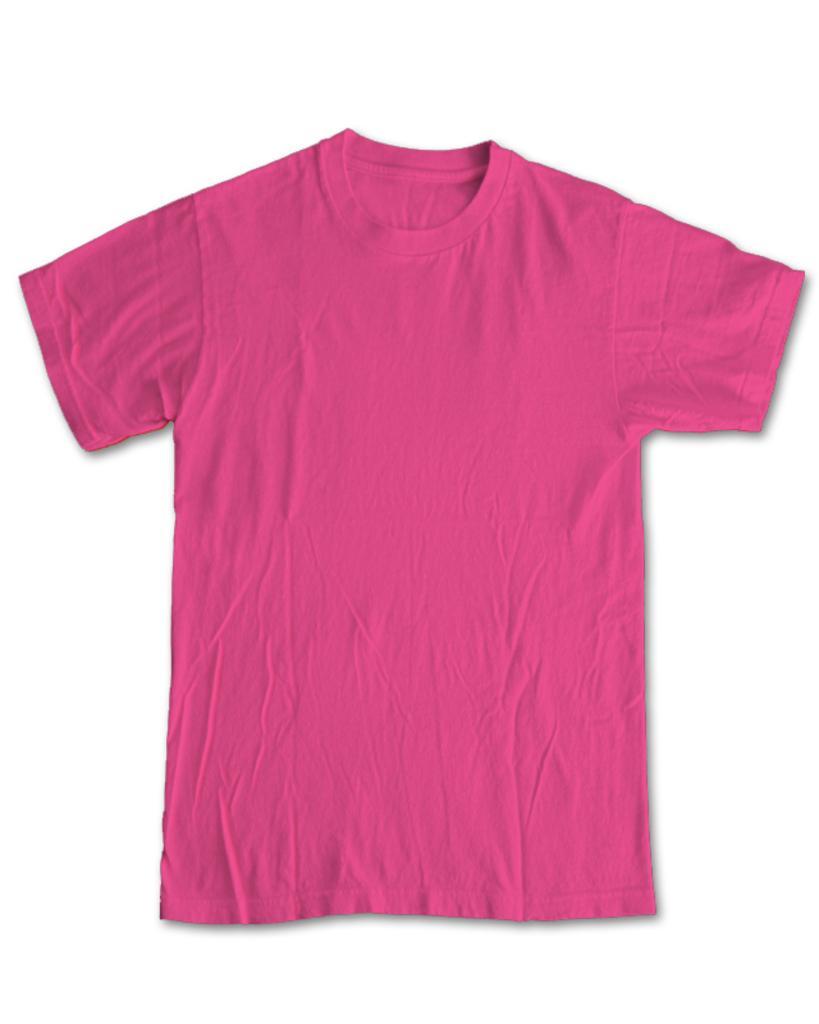How would you summarize this image in a sentence or two? This image consists of a T-shirt in pink color. The background is white in color. 